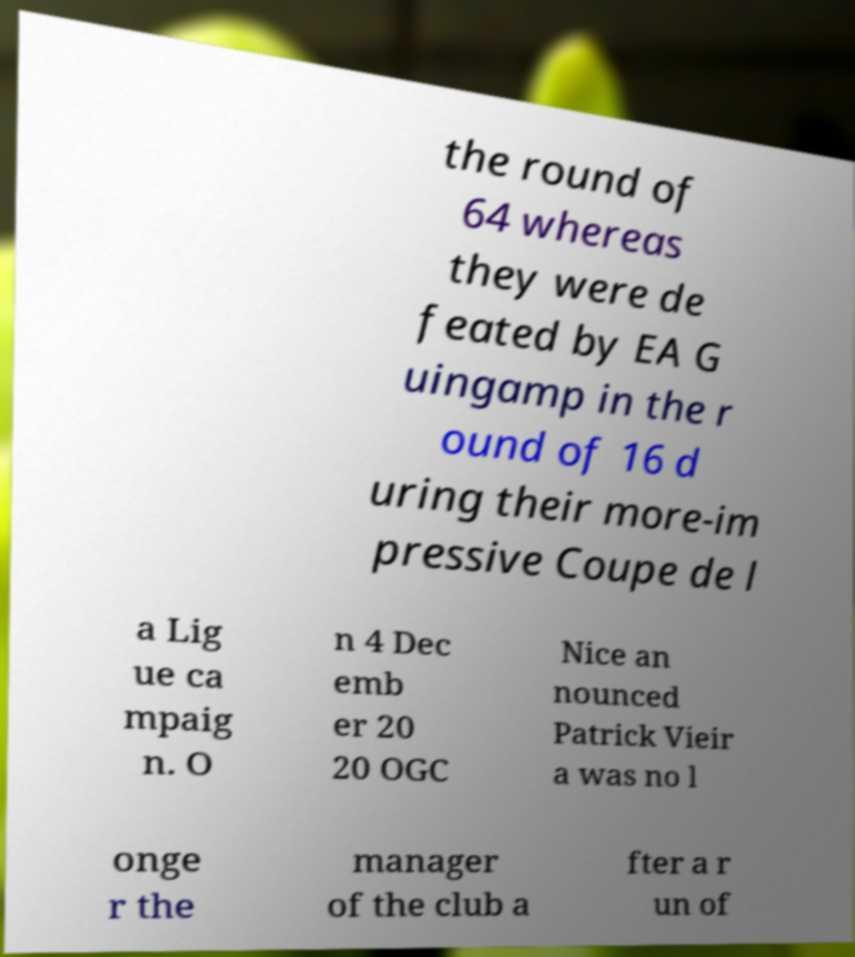What messages or text are displayed in this image? I need them in a readable, typed format. the round of 64 whereas they were de feated by EA G uingamp in the r ound of 16 d uring their more-im pressive Coupe de l a Lig ue ca mpaig n. O n 4 Dec emb er 20 20 OGC Nice an nounced Patrick Vieir a was no l onge r the manager of the club a fter a r un of 